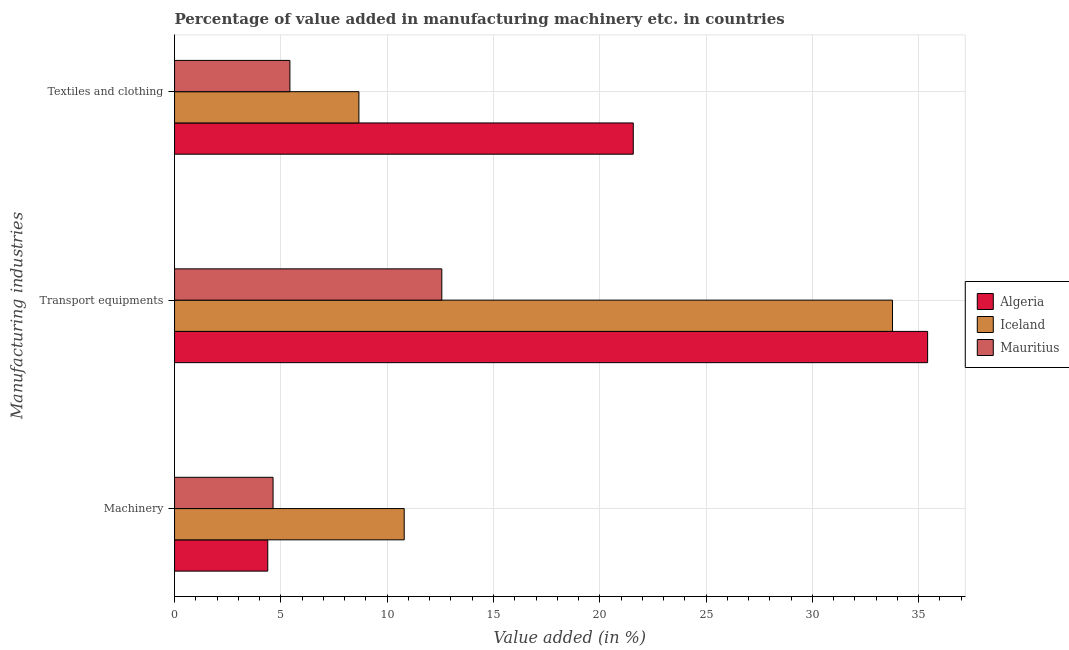How many groups of bars are there?
Your answer should be very brief. 3. Are the number of bars per tick equal to the number of legend labels?
Provide a short and direct response. Yes. How many bars are there on the 2nd tick from the bottom?
Provide a succinct answer. 3. What is the label of the 3rd group of bars from the top?
Your answer should be compact. Machinery. What is the value added in manufacturing textile and clothing in Iceland?
Offer a very short reply. 8.67. Across all countries, what is the maximum value added in manufacturing machinery?
Give a very brief answer. 10.8. Across all countries, what is the minimum value added in manufacturing textile and clothing?
Make the answer very short. 5.43. In which country was the value added in manufacturing textile and clothing maximum?
Keep it short and to the point. Algeria. In which country was the value added in manufacturing machinery minimum?
Offer a terse response. Algeria. What is the total value added in manufacturing transport equipments in the graph?
Provide a succinct answer. 81.76. What is the difference between the value added in manufacturing transport equipments in Mauritius and that in Iceland?
Your response must be concise. -21.2. What is the difference between the value added in manufacturing textile and clothing in Algeria and the value added in manufacturing machinery in Iceland?
Your response must be concise. 10.77. What is the average value added in manufacturing machinery per country?
Give a very brief answer. 6.61. What is the difference between the value added in manufacturing textile and clothing and value added in manufacturing machinery in Algeria?
Provide a short and direct response. 17.19. What is the ratio of the value added in manufacturing transport equipments in Mauritius to that in Iceland?
Your answer should be very brief. 0.37. Is the value added in manufacturing textile and clothing in Iceland less than that in Algeria?
Ensure brevity in your answer.  Yes. Is the difference between the value added in manufacturing transport equipments in Mauritius and Iceland greater than the difference between the value added in manufacturing textile and clothing in Mauritius and Iceland?
Offer a very short reply. No. What is the difference between the highest and the second highest value added in manufacturing transport equipments?
Keep it short and to the point. 1.65. What is the difference between the highest and the lowest value added in manufacturing transport equipments?
Offer a terse response. 22.85. In how many countries, is the value added in manufacturing machinery greater than the average value added in manufacturing machinery taken over all countries?
Your answer should be compact. 1. Is the sum of the value added in manufacturing machinery in Mauritius and Algeria greater than the maximum value added in manufacturing textile and clothing across all countries?
Your answer should be compact. No. What does the 1st bar from the top in Transport equipments represents?
Keep it short and to the point. Mauritius. What does the 1st bar from the bottom in Transport equipments represents?
Give a very brief answer. Algeria. Is it the case that in every country, the sum of the value added in manufacturing machinery and value added in manufacturing transport equipments is greater than the value added in manufacturing textile and clothing?
Your answer should be compact. Yes. How many bars are there?
Ensure brevity in your answer.  9. What is the difference between two consecutive major ticks on the X-axis?
Your response must be concise. 5. Does the graph contain grids?
Offer a very short reply. Yes. How many legend labels are there?
Offer a very short reply. 3. What is the title of the graph?
Offer a very short reply. Percentage of value added in manufacturing machinery etc. in countries. What is the label or title of the X-axis?
Offer a terse response. Value added (in %). What is the label or title of the Y-axis?
Provide a succinct answer. Manufacturing industries. What is the Value added (in %) in Algeria in Machinery?
Make the answer very short. 4.38. What is the Value added (in %) in Iceland in Machinery?
Make the answer very short. 10.8. What is the Value added (in %) in Mauritius in Machinery?
Ensure brevity in your answer.  4.63. What is the Value added (in %) of Algeria in Transport equipments?
Your answer should be compact. 35.42. What is the Value added (in %) of Iceland in Transport equipments?
Offer a terse response. 33.77. What is the Value added (in %) in Mauritius in Transport equipments?
Provide a succinct answer. 12.57. What is the Value added (in %) in Algeria in Textiles and clothing?
Your response must be concise. 21.57. What is the Value added (in %) in Iceland in Textiles and clothing?
Offer a very short reply. 8.67. What is the Value added (in %) of Mauritius in Textiles and clothing?
Give a very brief answer. 5.43. Across all Manufacturing industries, what is the maximum Value added (in %) of Algeria?
Offer a terse response. 35.42. Across all Manufacturing industries, what is the maximum Value added (in %) of Iceland?
Your response must be concise. 33.77. Across all Manufacturing industries, what is the maximum Value added (in %) of Mauritius?
Keep it short and to the point. 12.57. Across all Manufacturing industries, what is the minimum Value added (in %) of Algeria?
Provide a succinct answer. 4.38. Across all Manufacturing industries, what is the minimum Value added (in %) in Iceland?
Provide a succinct answer. 8.67. Across all Manufacturing industries, what is the minimum Value added (in %) in Mauritius?
Your answer should be very brief. 4.63. What is the total Value added (in %) of Algeria in the graph?
Give a very brief answer. 61.38. What is the total Value added (in %) of Iceland in the graph?
Offer a terse response. 53.24. What is the total Value added (in %) of Mauritius in the graph?
Give a very brief answer. 22.63. What is the difference between the Value added (in %) of Algeria in Machinery and that in Transport equipments?
Give a very brief answer. -31.04. What is the difference between the Value added (in %) in Iceland in Machinery and that in Transport equipments?
Your answer should be compact. -22.97. What is the difference between the Value added (in %) of Mauritius in Machinery and that in Transport equipments?
Make the answer very short. -7.94. What is the difference between the Value added (in %) in Algeria in Machinery and that in Textiles and clothing?
Give a very brief answer. -17.19. What is the difference between the Value added (in %) in Iceland in Machinery and that in Textiles and clothing?
Ensure brevity in your answer.  2.13. What is the difference between the Value added (in %) of Mauritius in Machinery and that in Textiles and clothing?
Offer a very short reply. -0.79. What is the difference between the Value added (in %) of Algeria in Transport equipments and that in Textiles and clothing?
Your answer should be compact. 13.84. What is the difference between the Value added (in %) of Iceland in Transport equipments and that in Textiles and clothing?
Your response must be concise. 25.1. What is the difference between the Value added (in %) of Mauritius in Transport equipments and that in Textiles and clothing?
Your answer should be very brief. 7.14. What is the difference between the Value added (in %) of Algeria in Machinery and the Value added (in %) of Iceland in Transport equipments?
Your response must be concise. -29.38. What is the difference between the Value added (in %) in Algeria in Machinery and the Value added (in %) in Mauritius in Transport equipments?
Offer a terse response. -8.19. What is the difference between the Value added (in %) of Iceland in Machinery and the Value added (in %) of Mauritius in Transport equipments?
Your answer should be very brief. -1.77. What is the difference between the Value added (in %) in Algeria in Machinery and the Value added (in %) in Iceland in Textiles and clothing?
Make the answer very short. -4.29. What is the difference between the Value added (in %) in Algeria in Machinery and the Value added (in %) in Mauritius in Textiles and clothing?
Make the answer very short. -1.04. What is the difference between the Value added (in %) of Iceland in Machinery and the Value added (in %) of Mauritius in Textiles and clothing?
Offer a terse response. 5.38. What is the difference between the Value added (in %) in Algeria in Transport equipments and the Value added (in %) in Iceland in Textiles and clothing?
Make the answer very short. 26.75. What is the difference between the Value added (in %) of Algeria in Transport equipments and the Value added (in %) of Mauritius in Textiles and clothing?
Ensure brevity in your answer.  29.99. What is the difference between the Value added (in %) in Iceland in Transport equipments and the Value added (in %) in Mauritius in Textiles and clothing?
Your answer should be compact. 28.34. What is the average Value added (in %) in Algeria per Manufacturing industries?
Ensure brevity in your answer.  20.46. What is the average Value added (in %) in Iceland per Manufacturing industries?
Your response must be concise. 17.75. What is the average Value added (in %) of Mauritius per Manufacturing industries?
Ensure brevity in your answer.  7.54. What is the difference between the Value added (in %) of Algeria and Value added (in %) of Iceland in Machinery?
Make the answer very short. -6.42. What is the difference between the Value added (in %) of Algeria and Value added (in %) of Mauritius in Machinery?
Offer a terse response. -0.25. What is the difference between the Value added (in %) of Iceland and Value added (in %) of Mauritius in Machinery?
Offer a very short reply. 6.17. What is the difference between the Value added (in %) in Algeria and Value added (in %) in Iceland in Transport equipments?
Your answer should be compact. 1.65. What is the difference between the Value added (in %) of Algeria and Value added (in %) of Mauritius in Transport equipments?
Your answer should be compact. 22.85. What is the difference between the Value added (in %) in Iceland and Value added (in %) in Mauritius in Transport equipments?
Make the answer very short. 21.2. What is the difference between the Value added (in %) in Algeria and Value added (in %) in Iceland in Textiles and clothing?
Your answer should be compact. 12.9. What is the difference between the Value added (in %) of Algeria and Value added (in %) of Mauritius in Textiles and clothing?
Provide a short and direct response. 16.15. What is the difference between the Value added (in %) in Iceland and Value added (in %) in Mauritius in Textiles and clothing?
Make the answer very short. 3.25. What is the ratio of the Value added (in %) of Algeria in Machinery to that in Transport equipments?
Your response must be concise. 0.12. What is the ratio of the Value added (in %) of Iceland in Machinery to that in Transport equipments?
Offer a very short reply. 0.32. What is the ratio of the Value added (in %) in Mauritius in Machinery to that in Transport equipments?
Ensure brevity in your answer.  0.37. What is the ratio of the Value added (in %) in Algeria in Machinery to that in Textiles and clothing?
Keep it short and to the point. 0.2. What is the ratio of the Value added (in %) of Iceland in Machinery to that in Textiles and clothing?
Your response must be concise. 1.25. What is the ratio of the Value added (in %) in Mauritius in Machinery to that in Textiles and clothing?
Your answer should be very brief. 0.85. What is the ratio of the Value added (in %) in Algeria in Transport equipments to that in Textiles and clothing?
Provide a succinct answer. 1.64. What is the ratio of the Value added (in %) in Iceland in Transport equipments to that in Textiles and clothing?
Give a very brief answer. 3.89. What is the ratio of the Value added (in %) of Mauritius in Transport equipments to that in Textiles and clothing?
Keep it short and to the point. 2.32. What is the difference between the highest and the second highest Value added (in %) in Algeria?
Keep it short and to the point. 13.84. What is the difference between the highest and the second highest Value added (in %) of Iceland?
Ensure brevity in your answer.  22.97. What is the difference between the highest and the second highest Value added (in %) of Mauritius?
Ensure brevity in your answer.  7.14. What is the difference between the highest and the lowest Value added (in %) in Algeria?
Your answer should be compact. 31.04. What is the difference between the highest and the lowest Value added (in %) of Iceland?
Offer a very short reply. 25.1. What is the difference between the highest and the lowest Value added (in %) of Mauritius?
Ensure brevity in your answer.  7.94. 